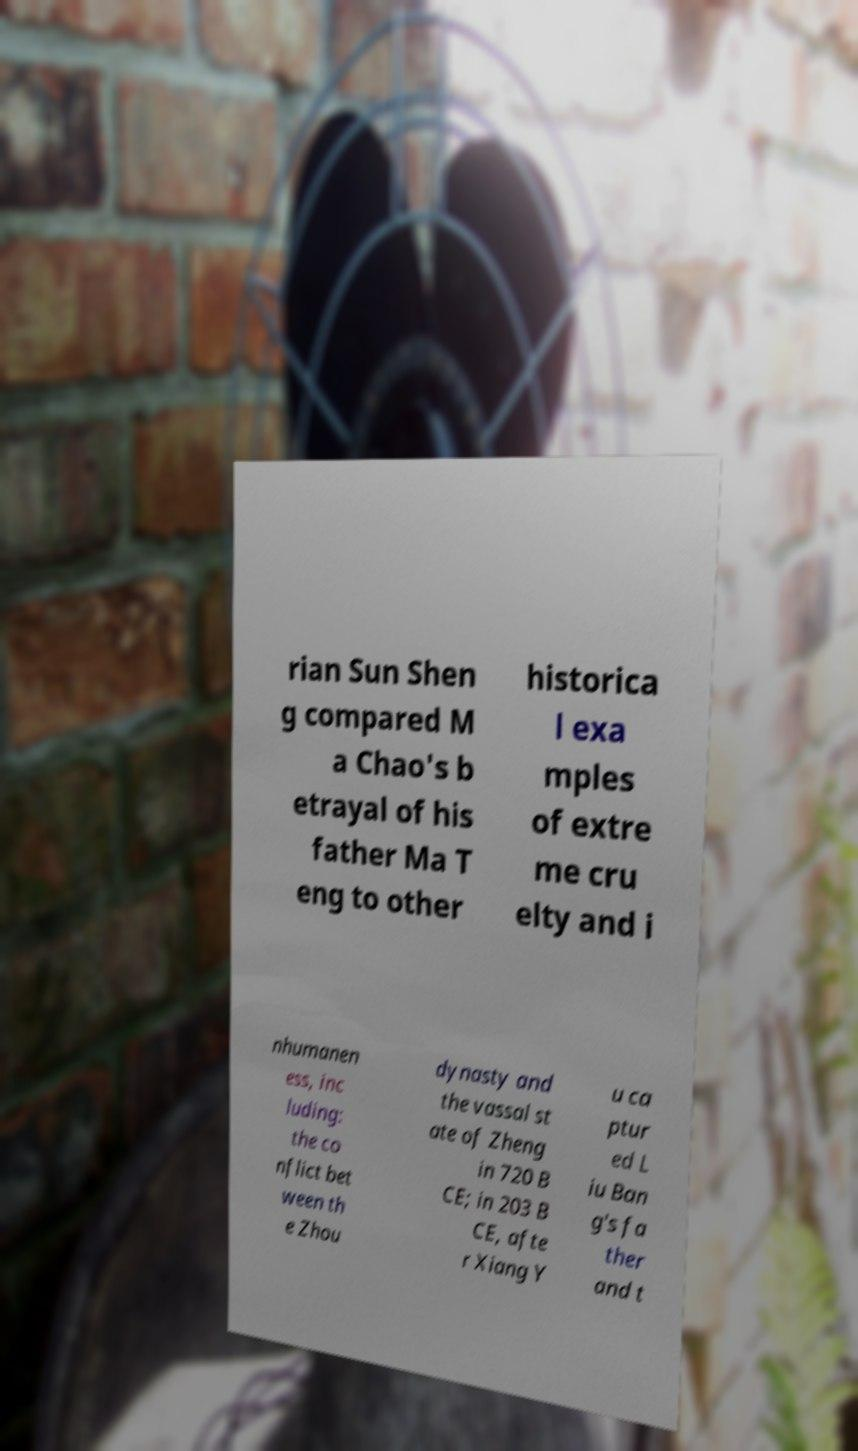Can you accurately transcribe the text from the provided image for me? rian Sun Shen g compared M a Chao's b etrayal of his father Ma T eng to other historica l exa mples of extre me cru elty and i nhumanen ess, inc luding: the co nflict bet ween th e Zhou dynasty and the vassal st ate of Zheng in 720 B CE; in 203 B CE, afte r Xiang Y u ca ptur ed L iu Ban g's fa ther and t 